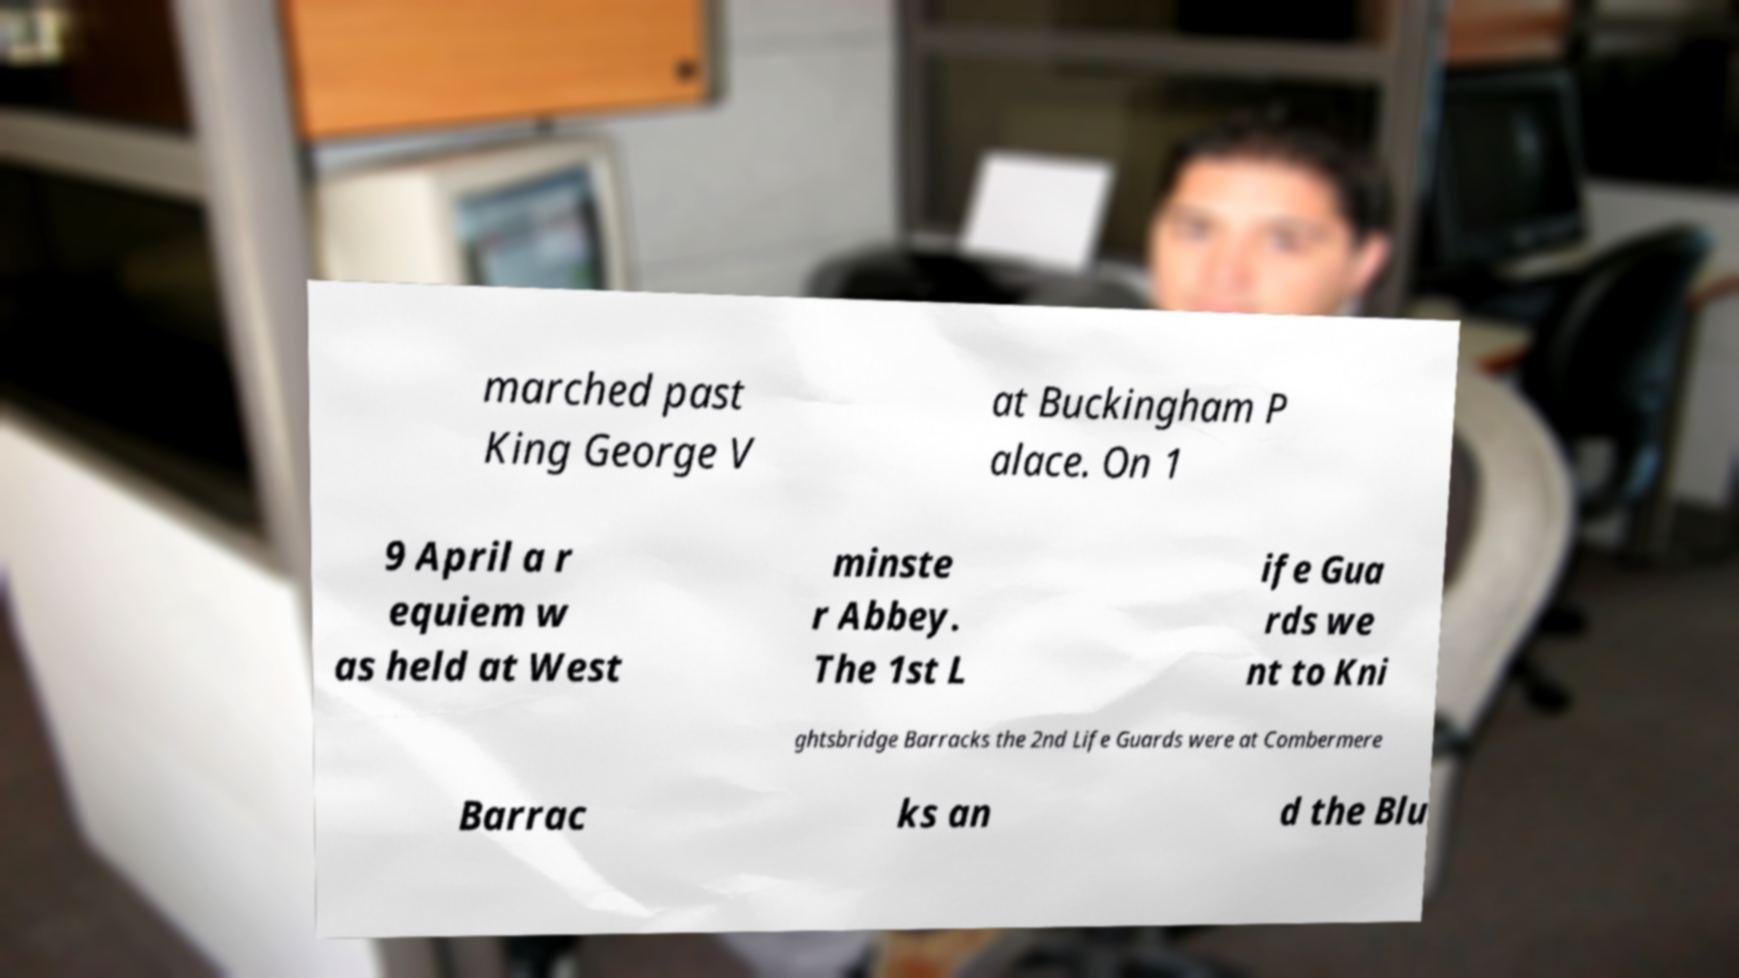For documentation purposes, I need the text within this image transcribed. Could you provide that? marched past King George V at Buckingham P alace. On 1 9 April a r equiem w as held at West minste r Abbey. The 1st L ife Gua rds we nt to Kni ghtsbridge Barracks the 2nd Life Guards were at Combermere Barrac ks an d the Blu 